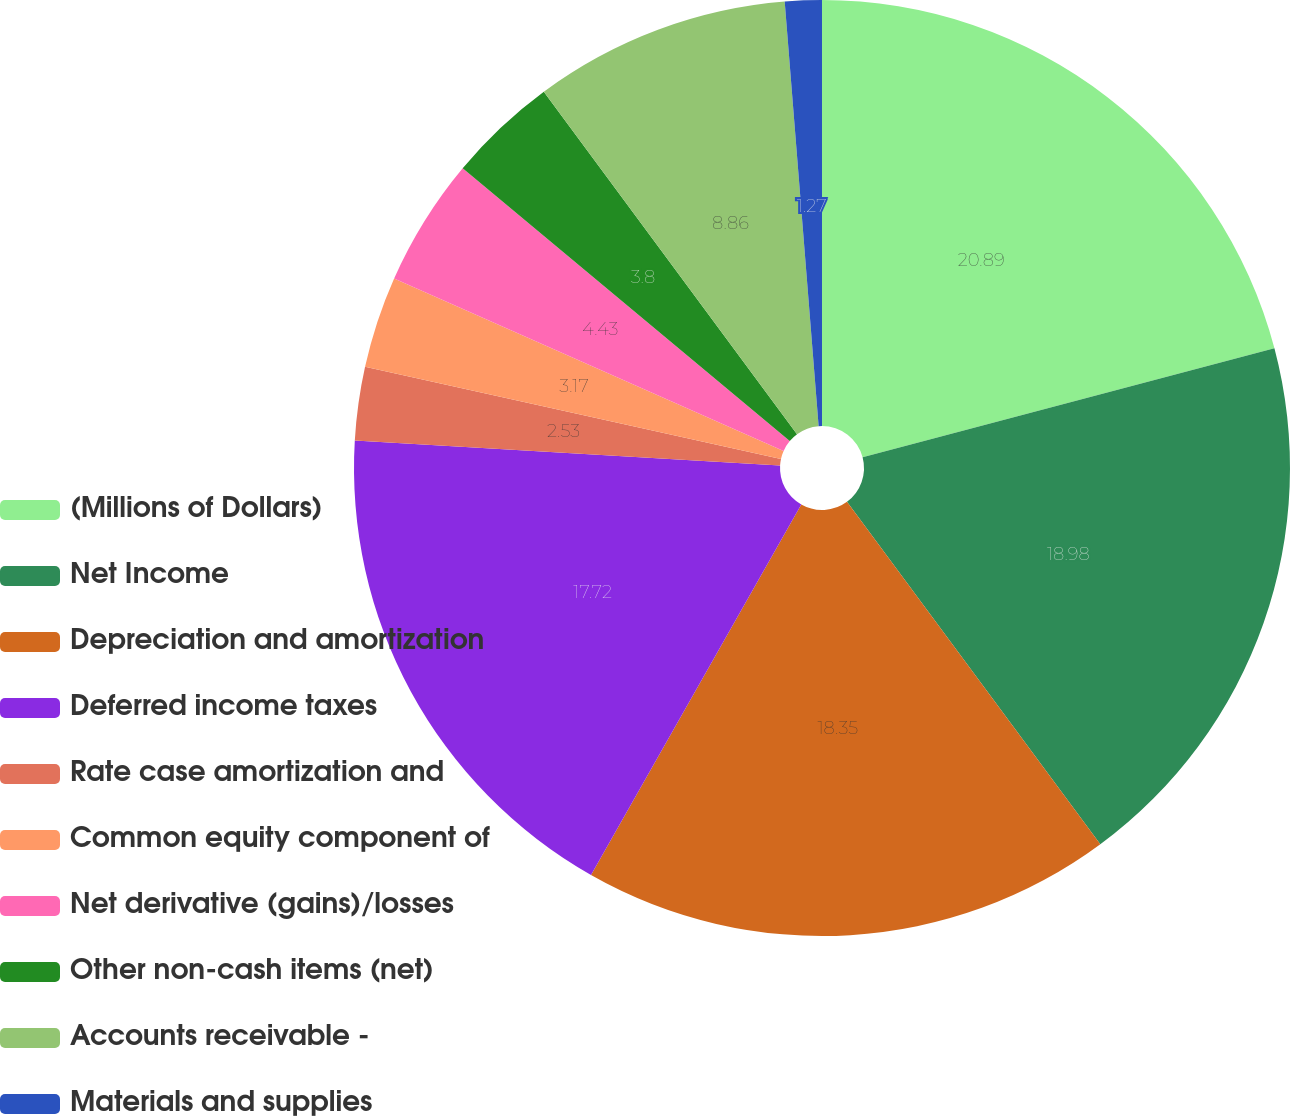Convert chart to OTSL. <chart><loc_0><loc_0><loc_500><loc_500><pie_chart><fcel>(Millions of Dollars)<fcel>Net Income<fcel>Depreciation and amortization<fcel>Deferred income taxes<fcel>Rate case amortization and<fcel>Common equity component of<fcel>Net derivative (gains)/losses<fcel>Other non-cash items (net)<fcel>Accounts receivable -<fcel>Materials and supplies<nl><fcel>20.88%<fcel>18.98%<fcel>18.35%<fcel>17.72%<fcel>2.53%<fcel>3.17%<fcel>4.43%<fcel>3.8%<fcel>8.86%<fcel>1.27%<nl></chart> 